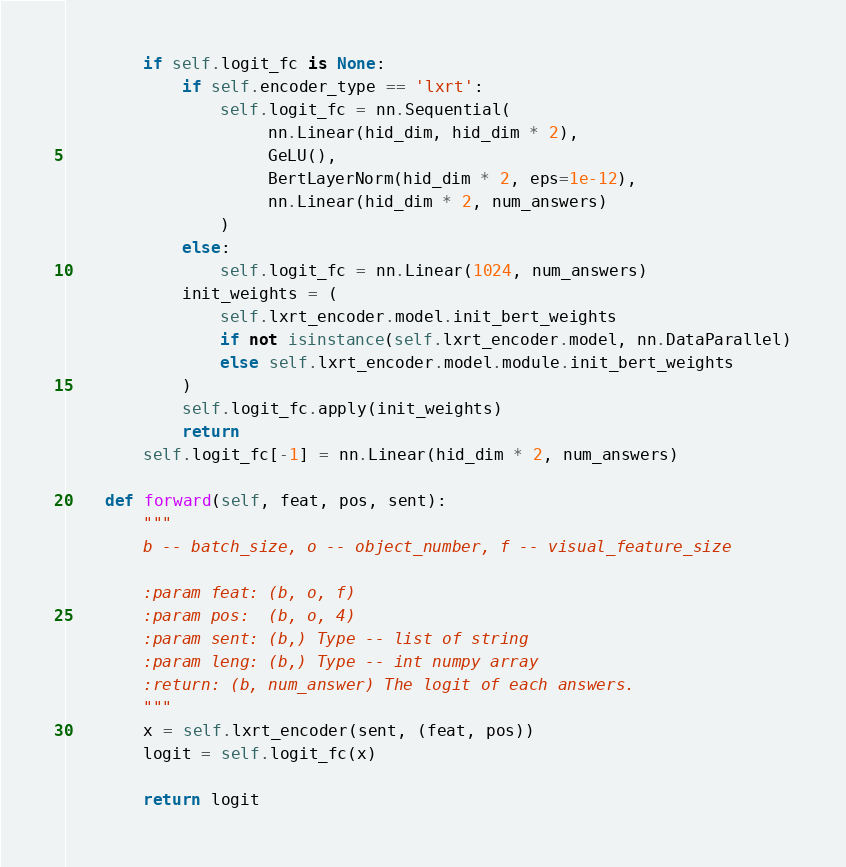Convert code to text. <code><loc_0><loc_0><loc_500><loc_500><_Python_>        if self.logit_fc is None:
            if self.encoder_type == 'lxrt':
                self.logit_fc = nn.Sequential(
                     nn.Linear(hid_dim, hid_dim * 2),
                     GeLU(),
                     BertLayerNorm(hid_dim * 2, eps=1e-12),
                     nn.Linear(hid_dim * 2, num_answers)
                )
            else:
                self.logit_fc = nn.Linear(1024, num_answers)
            init_weights = (
                self.lxrt_encoder.model.init_bert_weights
                if not isinstance(self.lxrt_encoder.model, nn.DataParallel)
                else self.lxrt_encoder.model.module.init_bert_weights
            )
            self.logit_fc.apply(init_weights)
            return
        self.logit_fc[-1] = nn.Linear(hid_dim * 2, num_answers)

    def forward(self, feat, pos, sent):
        """
        b -- batch_size, o -- object_number, f -- visual_feature_size

        :param feat: (b, o, f)
        :param pos:  (b, o, 4)
        :param sent: (b,) Type -- list of string
        :param leng: (b,) Type -- int numpy array
        :return: (b, num_answer) The logit of each answers.
        """
        x = self.lxrt_encoder(sent, (feat, pos))
        logit = self.logit_fc(x)

        return logit
</code> 